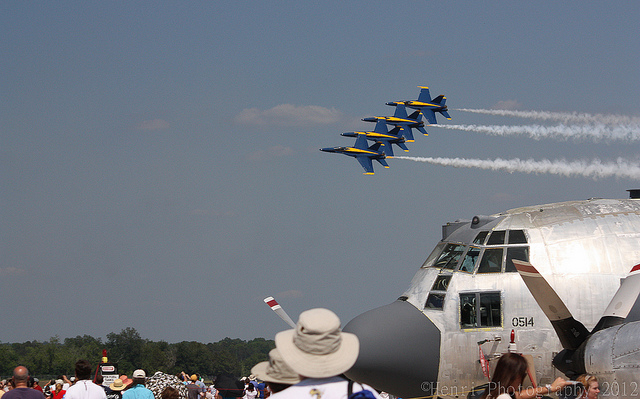Please extract the text content from this image. 0514 2012 Photography Henri 